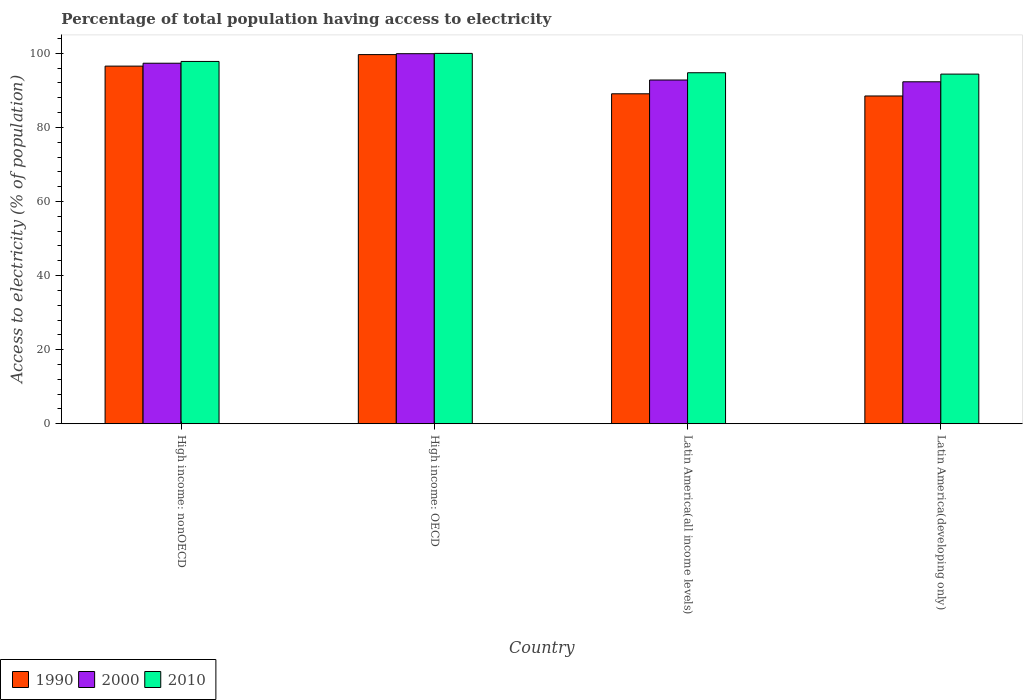How many groups of bars are there?
Make the answer very short. 4. Are the number of bars on each tick of the X-axis equal?
Provide a short and direct response. Yes. How many bars are there on the 1st tick from the right?
Ensure brevity in your answer.  3. What is the label of the 3rd group of bars from the left?
Ensure brevity in your answer.  Latin America(all income levels). In how many cases, is the number of bars for a given country not equal to the number of legend labels?
Your answer should be very brief. 0. What is the percentage of population that have access to electricity in 2000 in Latin America(developing only)?
Keep it short and to the point. 92.3. Across all countries, what is the maximum percentage of population that have access to electricity in 2000?
Make the answer very short. 99.89. Across all countries, what is the minimum percentage of population that have access to electricity in 2000?
Your answer should be very brief. 92.3. In which country was the percentage of population that have access to electricity in 2010 maximum?
Keep it short and to the point. High income: OECD. In which country was the percentage of population that have access to electricity in 2010 minimum?
Keep it short and to the point. Latin America(developing only). What is the total percentage of population that have access to electricity in 2010 in the graph?
Keep it short and to the point. 386.89. What is the difference between the percentage of population that have access to electricity in 2010 in High income: OECD and that in High income: nonOECD?
Offer a very short reply. 2.17. What is the difference between the percentage of population that have access to electricity in 2010 in Latin America(developing only) and the percentage of population that have access to electricity in 2000 in High income: OECD?
Give a very brief answer. -5.51. What is the average percentage of population that have access to electricity in 1990 per country?
Offer a terse response. 93.43. What is the difference between the percentage of population that have access to electricity of/in 2000 and percentage of population that have access to electricity of/in 1990 in High income: nonOECD?
Ensure brevity in your answer.  0.78. What is the ratio of the percentage of population that have access to electricity in 1990 in High income: nonOECD to that in Latin America(all income levels)?
Your response must be concise. 1.08. What is the difference between the highest and the second highest percentage of population that have access to electricity in 2010?
Ensure brevity in your answer.  -2.17. What is the difference between the highest and the lowest percentage of population that have access to electricity in 2000?
Keep it short and to the point. 7.58. Is the sum of the percentage of population that have access to electricity in 2010 in Latin America(all income levels) and Latin America(developing only) greater than the maximum percentage of population that have access to electricity in 1990 across all countries?
Offer a very short reply. Yes. What does the 2nd bar from the left in Latin America(developing only) represents?
Your answer should be compact. 2000. What does the 3rd bar from the right in Latin America(developing only) represents?
Offer a terse response. 1990. How many bars are there?
Give a very brief answer. 12. Are all the bars in the graph horizontal?
Provide a short and direct response. No. How many countries are there in the graph?
Offer a terse response. 4. Does the graph contain any zero values?
Your answer should be very brief. No. Does the graph contain grids?
Your response must be concise. No. Where does the legend appear in the graph?
Provide a succinct answer. Bottom left. What is the title of the graph?
Provide a succinct answer. Percentage of total population having access to electricity. What is the label or title of the Y-axis?
Your answer should be very brief. Access to electricity (% of population). What is the Access to electricity (% of population) in 1990 in High income: nonOECD?
Ensure brevity in your answer.  96.53. What is the Access to electricity (% of population) in 2000 in High income: nonOECD?
Your response must be concise. 97.31. What is the Access to electricity (% of population) in 2010 in High income: nonOECD?
Offer a terse response. 97.8. What is the Access to electricity (% of population) in 1990 in High income: OECD?
Your answer should be very brief. 99.64. What is the Access to electricity (% of population) in 2000 in High income: OECD?
Keep it short and to the point. 99.89. What is the Access to electricity (% of population) of 2010 in High income: OECD?
Keep it short and to the point. 99.97. What is the Access to electricity (% of population) of 1990 in Latin America(all income levels)?
Offer a terse response. 89.06. What is the Access to electricity (% of population) of 2000 in Latin America(all income levels)?
Provide a succinct answer. 92.78. What is the Access to electricity (% of population) of 2010 in Latin America(all income levels)?
Offer a terse response. 94.75. What is the Access to electricity (% of population) of 1990 in Latin America(developing only)?
Ensure brevity in your answer.  88.48. What is the Access to electricity (% of population) of 2000 in Latin America(developing only)?
Keep it short and to the point. 92.3. What is the Access to electricity (% of population) in 2010 in Latin America(developing only)?
Make the answer very short. 94.38. Across all countries, what is the maximum Access to electricity (% of population) in 1990?
Keep it short and to the point. 99.64. Across all countries, what is the maximum Access to electricity (% of population) of 2000?
Your response must be concise. 99.89. Across all countries, what is the maximum Access to electricity (% of population) in 2010?
Provide a short and direct response. 99.97. Across all countries, what is the minimum Access to electricity (% of population) of 1990?
Give a very brief answer. 88.48. Across all countries, what is the minimum Access to electricity (% of population) of 2000?
Provide a succinct answer. 92.3. Across all countries, what is the minimum Access to electricity (% of population) in 2010?
Offer a terse response. 94.38. What is the total Access to electricity (% of population) in 1990 in the graph?
Provide a succinct answer. 373.72. What is the total Access to electricity (% of population) of 2000 in the graph?
Keep it short and to the point. 382.29. What is the total Access to electricity (% of population) in 2010 in the graph?
Your answer should be very brief. 386.89. What is the difference between the Access to electricity (% of population) in 1990 in High income: nonOECD and that in High income: OECD?
Offer a very short reply. -3.11. What is the difference between the Access to electricity (% of population) of 2000 in High income: nonOECD and that in High income: OECD?
Your answer should be very brief. -2.57. What is the difference between the Access to electricity (% of population) of 2010 in High income: nonOECD and that in High income: OECD?
Offer a terse response. -2.17. What is the difference between the Access to electricity (% of population) in 1990 in High income: nonOECD and that in Latin America(all income levels)?
Offer a very short reply. 7.47. What is the difference between the Access to electricity (% of population) in 2000 in High income: nonOECD and that in Latin America(all income levels)?
Your answer should be compact. 4.53. What is the difference between the Access to electricity (% of population) in 2010 in High income: nonOECD and that in Latin America(all income levels)?
Provide a short and direct response. 3.05. What is the difference between the Access to electricity (% of population) in 1990 in High income: nonOECD and that in Latin America(developing only)?
Make the answer very short. 8.06. What is the difference between the Access to electricity (% of population) of 2000 in High income: nonOECD and that in Latin America(developing only)?
Your response must be concise. 5.01. What is the difference between the Access to electricity (% of population) in 2010 in High income: nonOECD and that in Latin America(developing only)?
Your answer should be very brief. 3.42. What is the difference between the Access to electricity (% of population) in 1990 in High income: OECD and that in Latin America(all income levels)?
Your answer should be compact. 10.58. What is the difference between the Access to electricity (% of population) in 2000 in High income: OECD and that in Latin America(all income levels)?
Provide a short and direct response. 7.1. What is the difference between the Access to electricity (% of population) in 2010 in High income: OECD and that in Latin America(all income levels)?
Your answer should be compact. 5.22. What is the difference between the Access to electricity (% of population) of 1990 in High income: OECD and that in Latin America(developing only)?
Your answer should be very brief. 11.17. What is the difference between the Access to electricity (% of population) in 2000 in High income: OECD and that in Latin America(developing only)?
Give a very brief answer. 7.58. What is the difference between the Access to electricity (% of population) of 2010 in High income: OECD and that in Latin America(developing only)?
Give a very brief answer. 5.59. What is the difference between the Access to electricity (% of population) of 1990 in Latin America(all income levels) and that in Latin America(developing only)?
Ensure brevity in your answer.  0.59. What is the difference between the Access to electricity (% of population) of 2000 in Latin America(all income levels) and that in Latin America(developing only)?
Provide a short and direct response. 0.48. What is the difference between the Access to electricity (% of population) of 2010 in Latin America(all income levels) and that in Latin America(developing only)?
Your response must be concise. 0.37. What is the difference between the Access to electricity (% of population) in 1990 in High income: nonOECD and the Access to electricity (% of population) in 2000 in High income: OECD?
Give a very brief answer. -3.35. What is the difference between the Access to electricity (% of population) in 1990 in High income: nonOECD and the Access to electricity (% of population) in 2010 in High income: OECD?
Give a very brief answer. -3.44. What is the difference between the Access to electricity (% of population) of 2000 in High income: nonOECD and the Access to electricity (% of population) of 2010 in High income: OECD?
Offer a terse response. -2.66. What is the difference between the Access to electricity (% of population) in 1990 in High income: nonOECD and the Access to electricity (% of population) in 2000 in Latin America(all income levels)?
Keep it short and to the point. 3.75. What is the difference between the Access to electricity (% of population) of 1990 in High income: nonOECD and the Access to electricity (% of population) of 2010 in Latin America(all income levels)?
Your answer should be very brief. 1.79. What is the difference between the Access to electricity (% of population) in 2000 in High income: nonOECD and the Access to electricity (% of population) in 2010 in Latin America(all income levels)?
Your answer should be very brief. 2.57. What is the difference between the Access to electricity (% of population) of 1990 in High income: nonOECD and the Access to electricity (% of population) of 2000 in Latin America(developing only)?
Provide a short and direct response. 4.23. What is the difference between the Access to electricity (% of population) of 1990 in High income: nonOECD and the Access to electricity (% of population) of 2010 in Latin America(developing only)?
Offer a very short reply. 2.16. What is the difference between the Access to electricity (% of population) in 2000 in High income: nonOECD and the Access to electricity (% of population) in 2010 in Latin America(developing only)?
Offer a terse response. 2.94. What is the difference between the Access to electricity (% of population) of 1990 in High income: OECD and the Access to electricity (% of population) of 2000 in Latin America(all income levels)?
Your answer should be very brief. 6.86. What is the difference between the Access to electricity (% of population) in 1990 in High income: OECD and the Access to electricity (% of population) in 2010 in Latin America(all income levels)?
Provide a succinct answer. 4.9. What is the difference between the Access to electricity (% of population) of 2000 in High income: OECD and the Access to electricity (% of population) of 2010 in Latin America(all income levels)?
Provide a succinct answer. 5.14. What is the difference between the Access to electricity (% of population) of 1990 in High income: OECD and the Access to electricity (% of population) of 2000 in Latin America(developing only)?
Give a very brief answer. 7.34. What is the difference between the Access to electricity (% of population) of 1990 in High income: OECD and the Access to electricity (% of population) of 2010 in Latin America(developing only)?
Keep it short and to the point. 5.27. What is the difference between the Access to electricity (% of population) in 2000 in High income: OECD and the Access to electricity (% of population) in 2010 in Latin America(developing only)?
Keep it short and to the point. 5.51. What is the difference between the Access to electricity (% of population) of 1990 in Latin America(all income levels) and the Access to electricity (% of population) of 2000 in Latin America(developing only)?
Provide a short and direct response. -3.24. What is the difference between the Access to electricity (% of population) of 1990 in Latin America(all income levels) and the Access to electricity (% of population) of 2010 in Latin America(developing only)?
Your answer should be very brief. -5.32. What is the difference between the Access to electricity (% of population) of 2000 in Latin America(all income levels) and the Access to electricity (% of population) of 2010 in Latin America(developing only)?
Ensure brevity in your answer.  -1.6. What is the average Access to electricity (% of population) in 1990 per country?
Give a very brief answer. 93.43. What is the average Access to electricity (% of population) of 2000 per country?
Your answer should be very brief. 95.57. What is the average Access to electricity (% of population) of 2010 per country?
Ensure brevity in your answer.  96.72. What is the difference between the Access to electricity (% of population) in 1990 and Access to electricity (% of population) in 2000 in High income: nonOECD?
Your answer should be compact. -0.78. What is the difference between the Access to electricity (% of population) of 1990 and Access to electricity (% of population) of 2010 in High income: nonOECD?
Your answer should be compact. -1.26. What is the difference between the Access to electricity (% of population) of 2000 and Access to electricity (% of population) of 2010 in High income: nonOECD?
Offer a terse response. -0.48. What is the difference between the Access to electricity (% of population) of 1990 and Access to electricity (% of population) of 2000 in High income: OECD?
Provide a short and direct response. -0.24. What is the difference between the Access to electricity (% of population) of 1990 and Access to electricity (% of population) of 2010 in High income: OECD?
Offer a terse response. -0.33. What is the difference between the Access to electricity (% of population) of 2000 and Access to electricity (% of population) of 2010 in High income: OECD?
Offer a very short reply. -0.08. What is the difference between the Access to electricity (% of population) of 1990 and Access to electricity (% of population) of 2000 in Latin America(all income levels)?
Your response must be concise. -3.72. What is the difference between the Access to electricity (% of population) of 1990 and Access to electricity (% of population) of 2010 in Latin America(all income levels)?
Your answer should be compact. -5.68. What is the difference between the Access to electricity (% of population) of 2000 and Access to electricity (% of population) of 2010 in Latin America(all income levels)?
Offer a very short reply. -1.96. What is the difference between the Access to electricity (% of population) of 1990 and Access to electricity (% of population) of 2000 in Latin America(developing only)?
Your answer should be very brief. -3.83. What is the difference between the Access to electricity (% of population) of 1990 and Access to electricity (% of population) of 2010 in Latin America(developing only)?
Give a very brief answer. -5.9. What is the difference between the Access to electricity (% of population) in 2000 and Access to electricity (% of population) in 2010 in Latin America(developing only)?
Provide a short and direct response. -2.07. What is the ratio of the Access to electricity (% of population) of 1990 in High income: nonOECD to that in High income: OECD?
Give a very brief answer. 0.97. What is the ratio of the Access to electricity (% of population) of 2000 in High income: nonOECD to that in High income: OECD?
Provide a succinct answer. 0.97. What is the ratio of the Access to electricity (% of population) in 2010 in High income: nonOECD to that in High income: OECD?
Offer a terse response. 0.98. What is the ratio of the Access to electricity (% of population) in 1990 in High income: nonOECD to that in Latin America(all income levels)?
Provide a short and direct response. 1.08. What is the ratio of the Access to electricity (% of population) in 2000 in High income: nonOECD to that in Latin America(all income levels)?
Offer a very short reply. 1.05. What is the ratio of the Access to electricity (% of population) of 2010 in High income: nonOECD to that in Latin America(all income levels)?
Keep it short and to the point. 1.03. What is the ratio of the Access to electricity (% of population) of 1990 in High income: nonOECD to that in Latin America(developing only)?
Your answer should be very brief. 1.09. What is the ratio of the Access to electricity (% of population) in 2000 in High income: nonOECD to that in Latin America(developing only)?
Offer a very short reply. 1.05. What is the ratio of the Access to electricity (% of population) in 2010 in High income: nonOECD to that in Latin America(developing only)?
Offer a terse response. 1.04. What is the ratio of the Access to electricity (% of population) of 1990 in High income: OECD to that in Latin America(all income levels)?
Offer a terse response. 1.12. What is the ratio of the Access to electricity (% of population) in 2000 in High income: OECD to that in Latin America(all income levels)?
Your answer should be very brief. 1.08. What is the ratio of the Access to electricity (% of population) of 2010 in High income: OECD to that in Latin America(all income levels)?
Your response must be concise. 1.06. What is the ratio of the Access to electricity (% of population) of 1990 in High income: OECD to that in Latin America(developing only)?
Your response must be concise. 1.13. What is the ratio of the Access to electricity (% of population) of 2000 in High income: OECD to that in Latin America(developing only)?
Provide a succinct answer. 1.08. What is the ratio of the Access to electricity (% of population) in 2010 in High income: OECD to that in Latin America(developing only)?
Offer a terse response. 1.06. What is the ratio of the Access to electricity (% of population) in 1990 in Latin America(all income levels) to that in Latin America(developing only)?
Provide a succinct answer. 1.01. What is the ratio of the Access to electricity (% of population) in 2000 in Latin America(all income levels) to that in Latin America(developing only)?
Offer a terse response. 1.01. What is the ratio of the Access to electricity (% of population) in 2010 in Latin America(all income levels) to that in Latin America(developing only)?
Provide a short and direct response. 1. What is the difference between the highest and the second highest Access to electricity (% of population) of 1990?
Provide a succinct answer. 3.11. What is the difference between the highest and the second highest Access to electricity (% of population) in 2000?
Ensure brevity in your answer.  2.57. What is the difference between the highest and the second highest Access to electricity (% of population) in 2010?
Ensure brevity in your answer.  2.17. What is the difference between the highest and the lowest Access to electricity (% of population) in 1990?
Your answer should be very brief. 11.17. What is the difference between the highest and the lowest Access to electricity (% of population) of 2000?
Keep it short and to the point. 7.58. What is the difference between the highest and the lowest Access to electricity (% of population) of 2010?
Offer a very short reply. 5.59. 